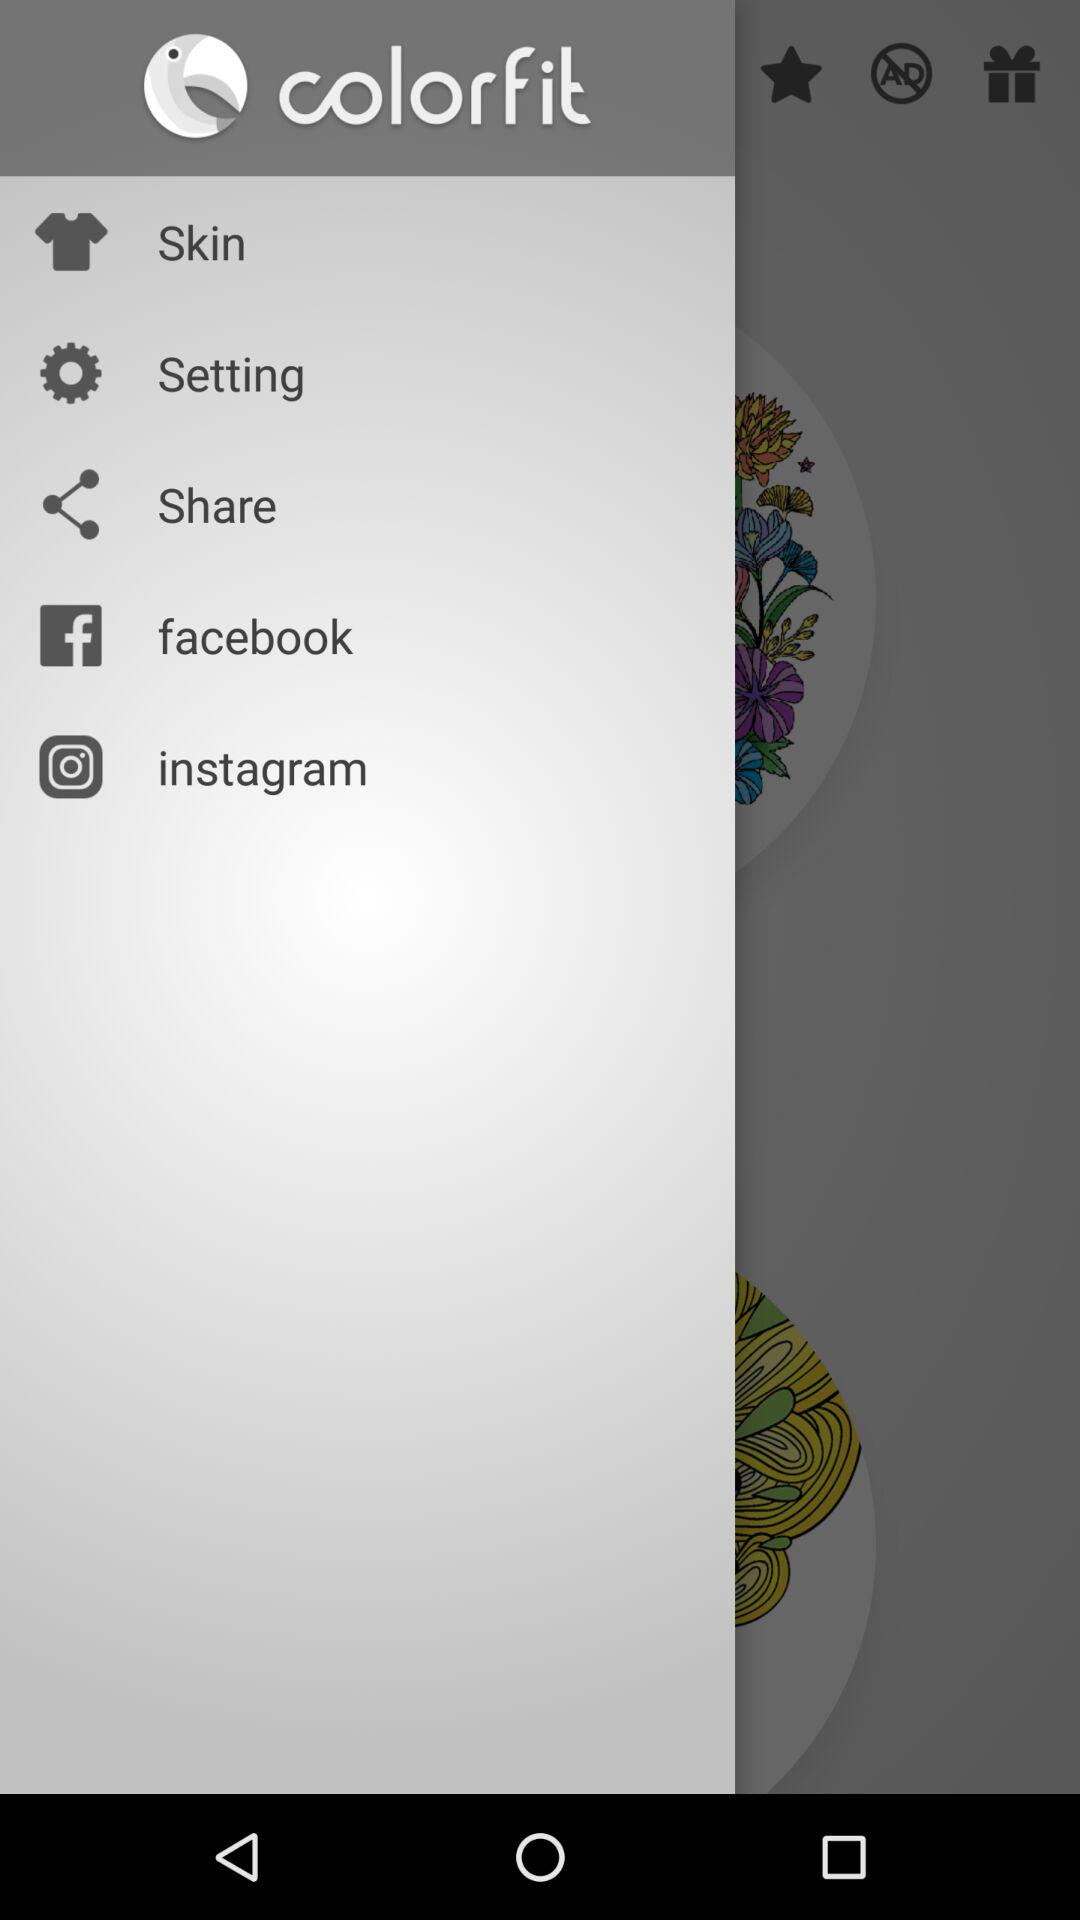What is the name of the application? The names of the applications are "colorfit", "facebook" and "instagram". 